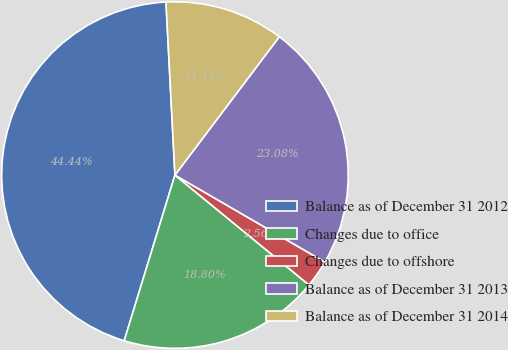Convert chart. <chart><loc_0><loc_0><loc_500><loc_500><pie_chart><fcel>Balance as of December 31 2012<fcel>Changes due to office<fcel>Changes due to offshore<fcel>Balance as of December 31 2013<fcel>Balance as of December 31 2014<nl><fcel>44.44%<fcel>18.8%<fcel>2.56%<fcel>23.08%<fcel>11.11%<nl></chart> 